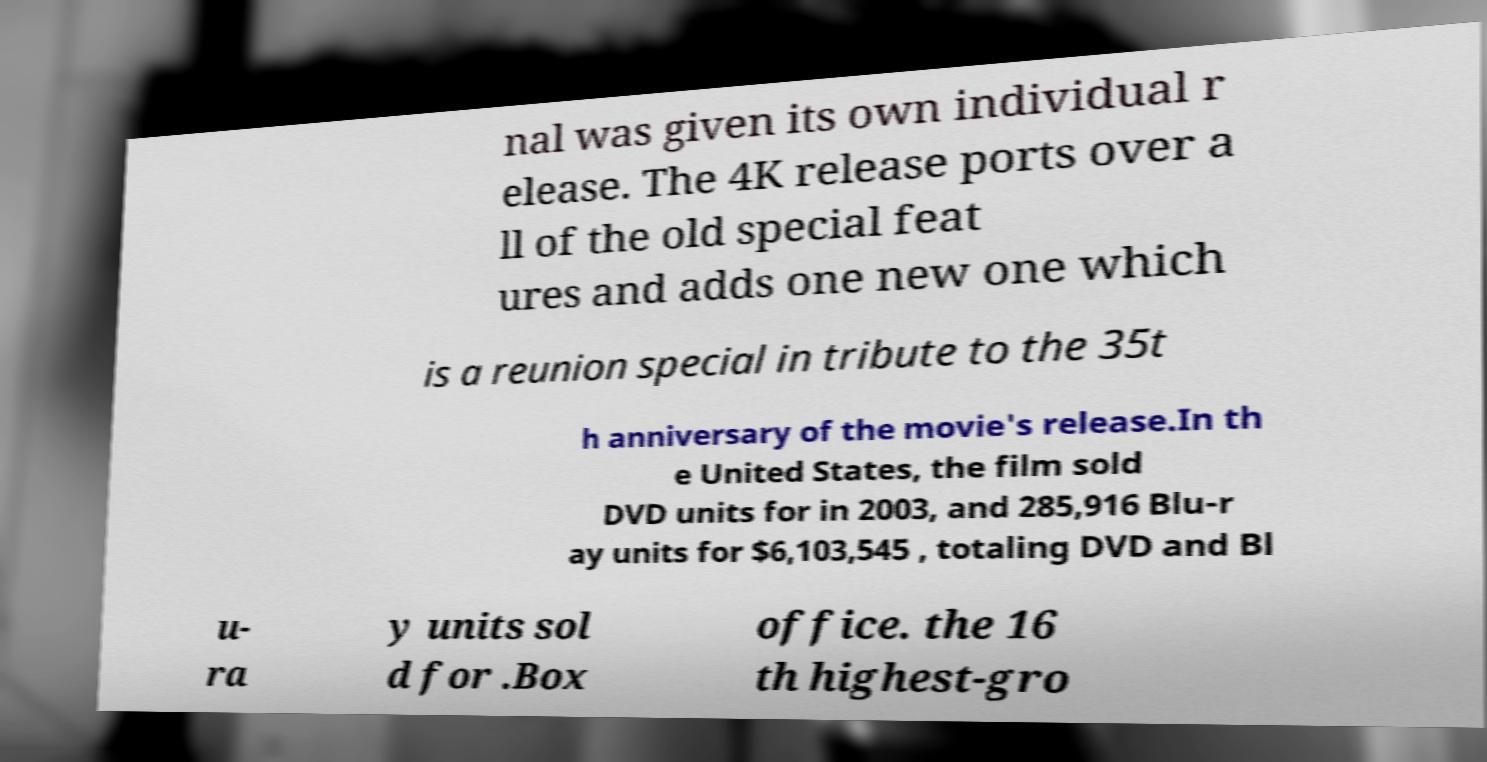Can you read and provide the text displayed in the image?This photo seems to have some interesting text. Can you extract and type it out for me? nal was given its own individual r elease. The 4K release ports over a ll of the old special feat ures and adds one new one which is a reunion special in tribute to the 35t h anniversary of the movie's release.In th e United States, the film sold DVD units for in 2003, and 285,916 Blu-r ay units for $6,103,545 , totaling DVD and Bl u- ra y units sol d for .Box office. the 16 th highest-gro 